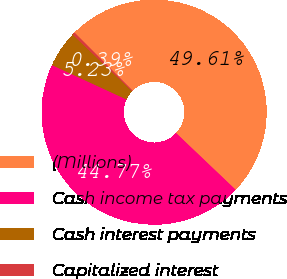<chart> <loc_0><loc_0><loc_500><loc_500><pie_chart><fcel>(Millions)<fcel>Cash income tax payments<fcel>Cash interest payments<fcel>Capitalized interest<nl><fcel>49.61%<fcel>44.77%<fcel>5.23%<fcel>0.39%<nl></chart> 